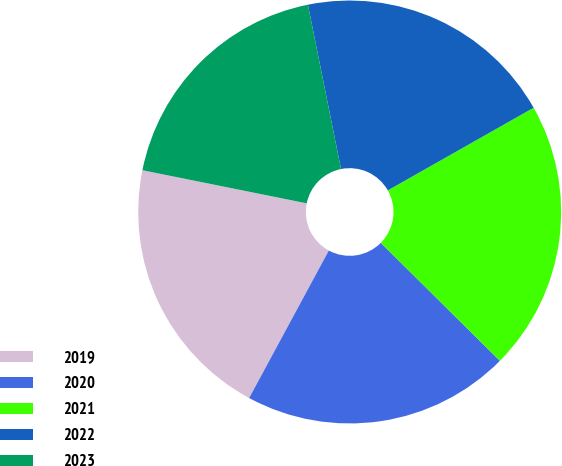<chart> <loc_0><loc_0><loc_500><loc_500><pie_chart><fcel>2019<fcel>2020<fcel>2021<fcel>2022<fcel>2023<nl><fcel>20.28%<fcel>20.46%<fcel>20.63%<fcel>19.96%<fcel>18.67%<nl></chart> 